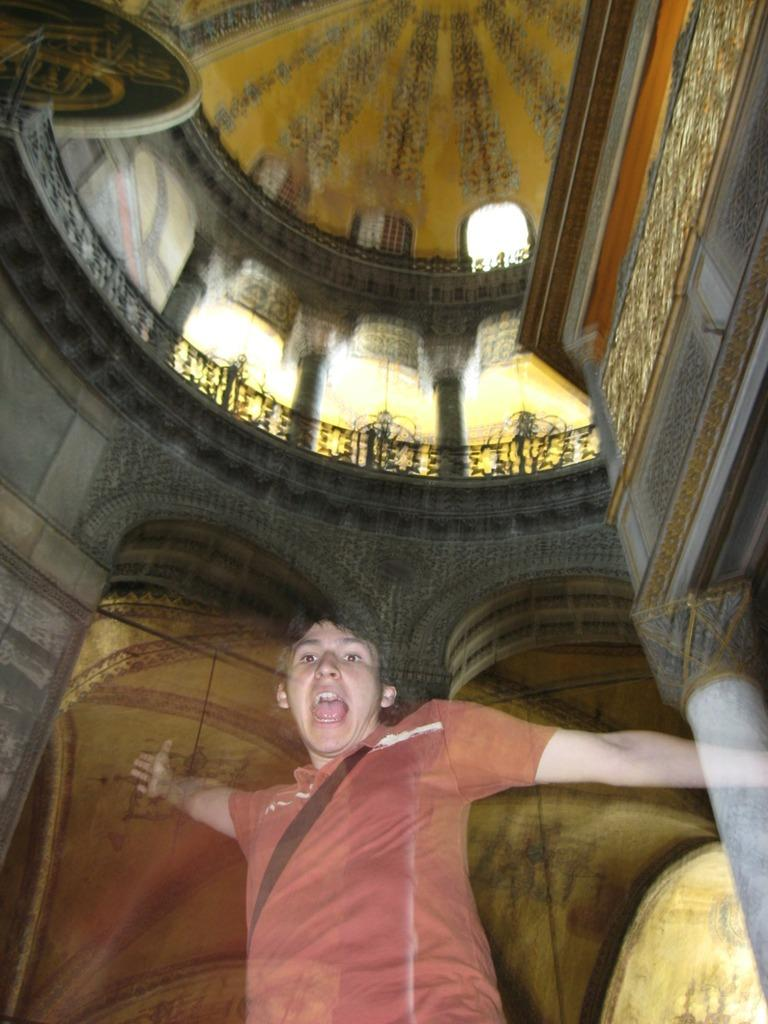What is the main subject in the center of the image? There is a person in the center of the image. What can be seen in the background of the image? There is a building in the background of the image. What type of music is the person in the image listening to? There is no indication in the image of the person listening to any music. What type of clothing material is the person wearing, such as leather or silk? The image does not provide enough detail to determine the type of clothing material the person is wearing. 